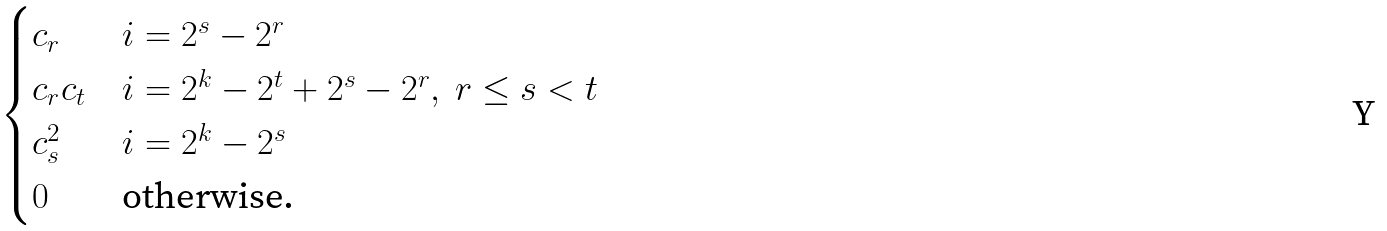Convert formula to latex. <formula><loc_0><loc_0><loc_500><loc_500>\begin{cases} c _ { r } & i = 2 ^ { s } - 2 ^ { r } \\ c _ { r } c _ { t } & i = 2 ^ { k } - 2 ^ { t } + 2 ^ { s } - 2 ^ { r } , \ r \leq s < t \\ c _ { s } ^ { 2 } & i = 2 ^ { k } - 2 ^ { s } \\ 0 & \text {otherwise.} \end{cases}</formula> 